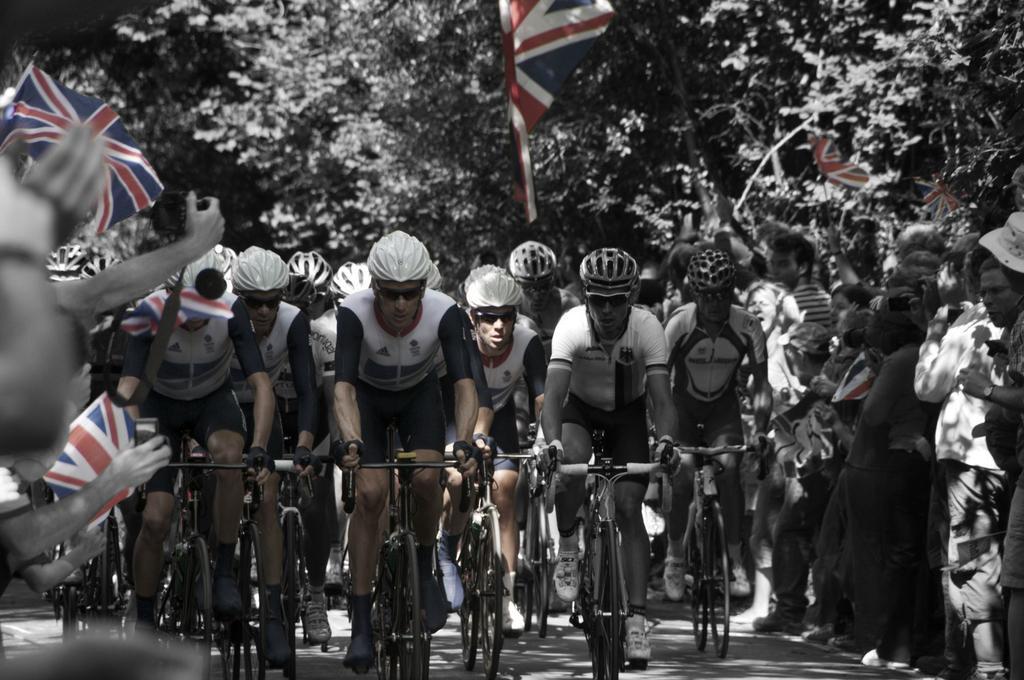How would you summarize this image in a sentence or two? In this picture there are many men cycling a bicycle, wearing a helmets and a spectacles. There are some people standing on the side of the road and watching them with flags, holding in their hands. In the background there are some trees. 